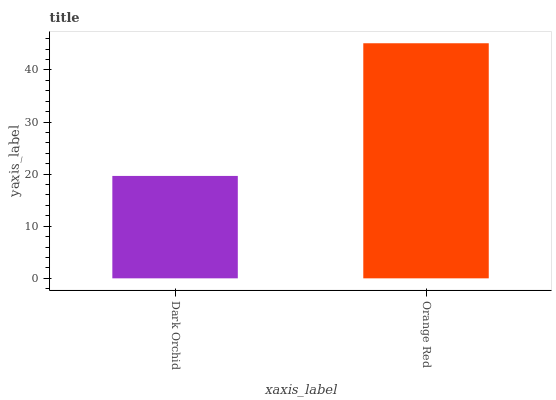Is Dark Orchid the minimum?
Answer yes or no. Yes. Is Orange Red the maximum?
Answer yes or no. Yes. Is Orange Red the minimum?
Answer yes or no. No. Is Orange Red greater than Dark Orchid?
Answer yes or no. Yes. Is Dark Orchid less than Orange Red?
Answer yes or no. Yes. Is Dark Orchid greater than Orange Red?
Answer yes or no. No. Is Orange Red less than Dark Orchid?
Answer yes or no. No. Is Orange Red the high median?
Answer yes or no. Yes. Is Dark Orchid the low median?
Answer yes or no. Yes. Is Dark Orchid the high median?
Answer yes or no. No. Is Orange Red the low median?
Answer yes or no. No. 